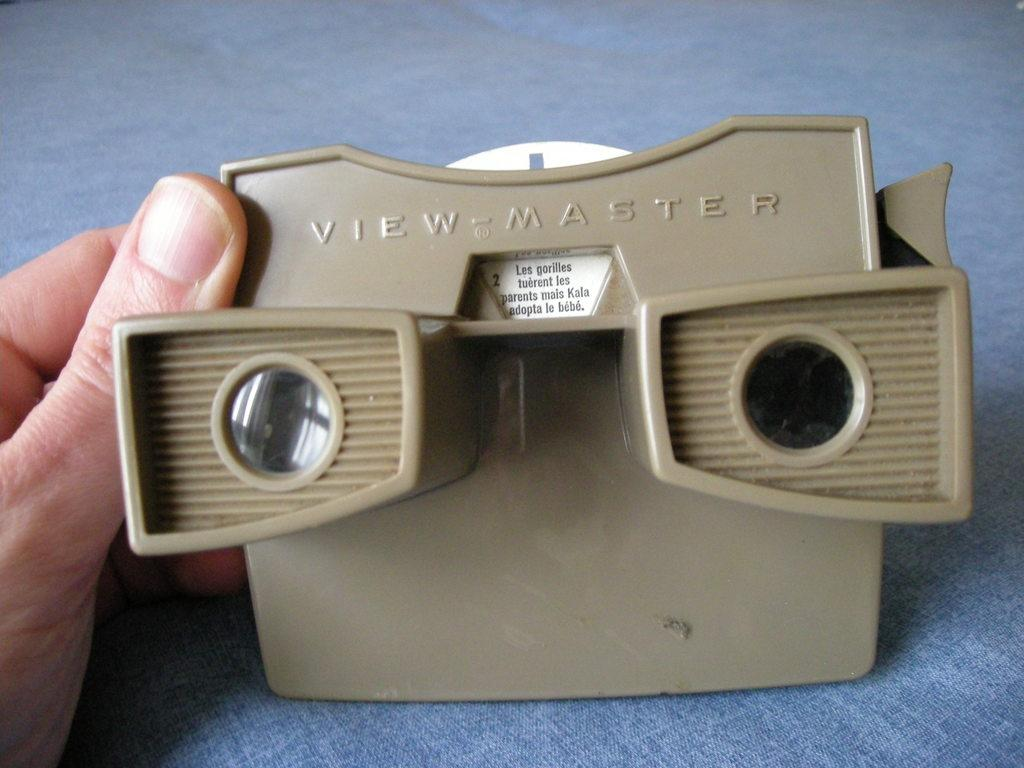What can be seen in the person's hand in the image? There is an object in the person's hand in the image. What is written on the object? There is writing on the object. What color is the surface the object is on? The object is on a blue surface. What type of orange is being used as a prop in the image? There is no orange present in the image; the object in the person's hand has writing on it and is on a blue surface. 